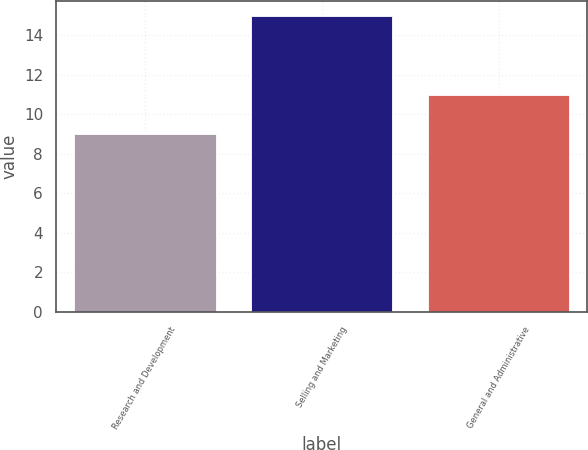Convert chart to OTSL. <chart><loc_0><loc_0><loc_500><loc_500><bar_chart><fcel>Research and Development<fcel>Selling and Marketing<fcel>General and Administrative<nl><fcel>9<fcel>15<fcel>11<nl></chart> 